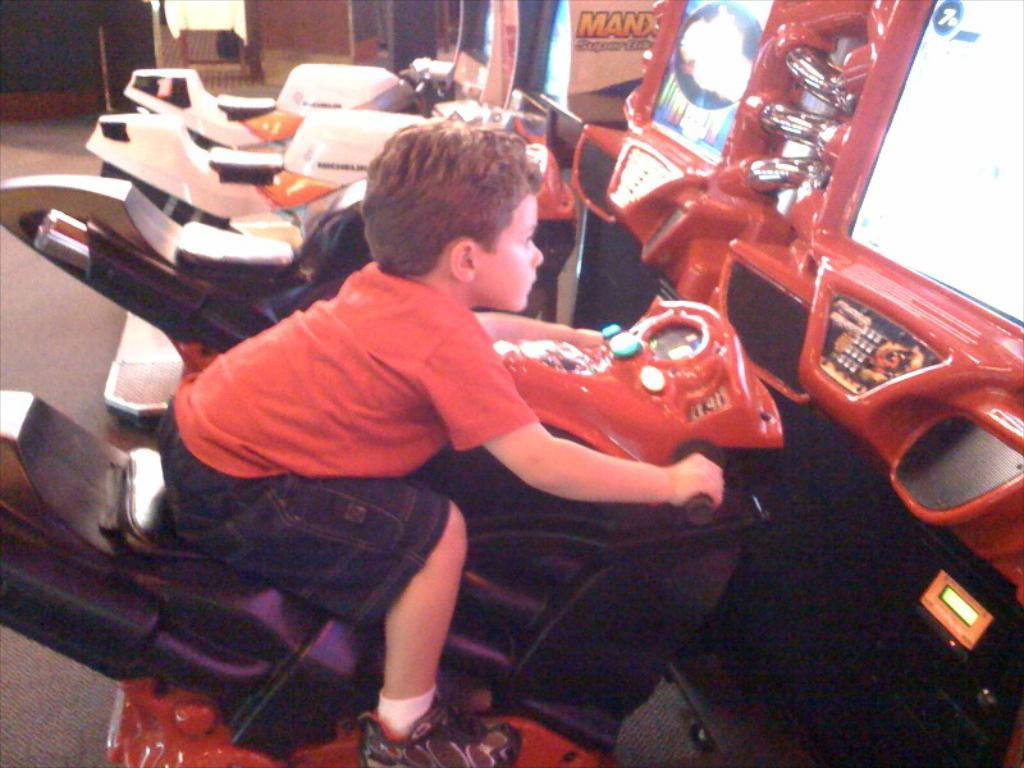Who is the main subject in the image? There is a boy in the image. What is the boy doing in the image? The boy is riding a bike in the image. Are there any other bikes visible in the image? Yes, there are other bikes visible in the image. What else can be seen in front of the boy? There are game stations in front of the boy. Can you see the boy's toe while he is riding the bike in the image? The image does not provide a close-up view of the boy's feet, so it is not possible to see his toe while he is riding the bike. 